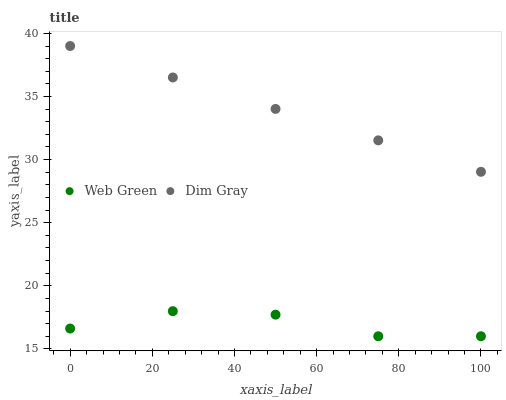Does Web Green have the minimum area under the curve?
Answer yes or no. Yes. Does Dim Gray have the maximum area under the curve?
Answer yes or no. Yes. Does Web Green have the maximum area under the curve?
Answer yes or no. No. Is Dim Gray the smoothest?
Answer yes or no. Yes. Is Web Green the roughest?
Answer yes or no. Yes. Is Web Green the smoothest?
Answer yes or no. No. Does Web Green have the lowest value?
Answer yes or no. Yes. Does Dim Gray have the highest value?
Answer yes or no. Yes. Does Web Green have the highest value?
Answer yes or no. No. Is Web Green less than Dim Gray?
Answer yes or no. Yes. Is Dim Gray greater than Web Green?
Answer yes or no. Yes. Does Web Green intersect Dim Gray?
Answer yes or no. No. 